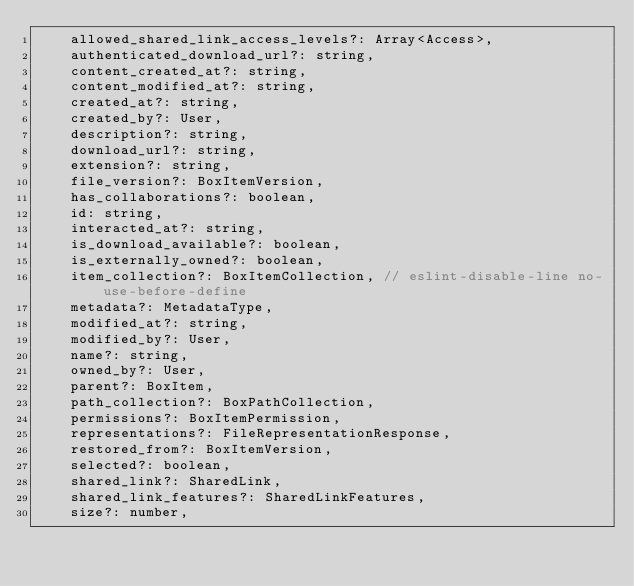Convert code to text. <code><loc_0><loc_0><loc_500><loc_500><_JavaScript_>    allowed_shared_link_access_levels?: Array<Access>,
    authenticated_download_url?: string,
    content_created_at?: string,
    content_modified_at?: string,
    created_at?: string,
    created_by?: User,
    description?: string,
    download_url?: string,
    extension?: string,
    file_version?: BoxItemVersion,
    has_collaborations?: boolean,
    id: string,
    interacted_at?: string,
    is_download_available?: boolean,
    is_externally_owned?: boolean,
    item_collection?: BoxItemCollection, // eslint-disable-line no-use-before-define
    metadata?: MetadataType,
    modified_at?: string,
    modified_by?: User,
    name?: string,
    owned_by?: User,
    parent?: BoxItem,
    path_collection?: BoxPathCollection,
    permissions?: BoxItemPermission,
    representations?: FileRepresentationResponse,
    restored_from?: BoxItemVersion,
    selected?: boolean,
    shared_link?: SharedLink,
    shared_link_features?: SharedLinkFeatures,
    size?: number,</code> 